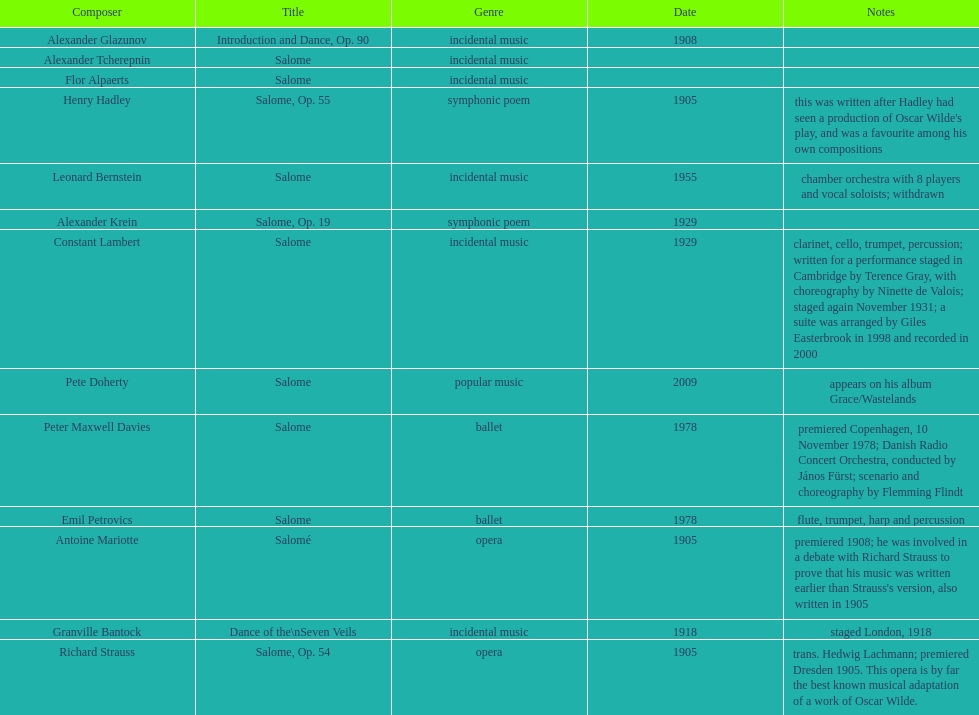How many works were made in the incidental music genre? 6. 